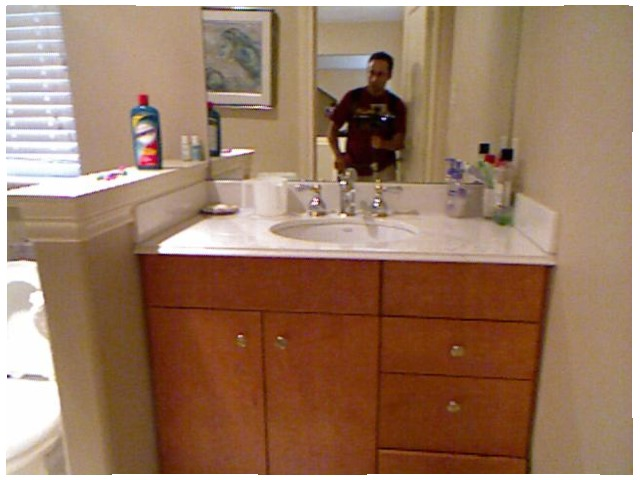<image>
Is the measuring cup on the sink? Yes. Looking at the image, I can see the measuring cup is positioned on top of the sink, with the sink providing support. Is there a man on the mirror? Yes. Looking at the image, I can see the man is positioned on top of the mirror, with the mirror providing support. Is the toilet next to the wall? Yes. The toilet is positioned adjacent to the wall, located nearby in the same general area. Is the man behind the sink? No. The man is not behind the sink. From this viewpoint, the man appears to be positioned elsewhere in the scene. Is the jug to the right of the tap? No. The jug is not to the right of the tap. The horizontal positioning shows a different relationship. Is there a mans reflection under the sink? No. The mans reflection is not positioned under the sink. The vertical relationship between these objects is different. Is the man in the mug? No. The man is not contained within the mug. These objects have a different spatial relationship. 